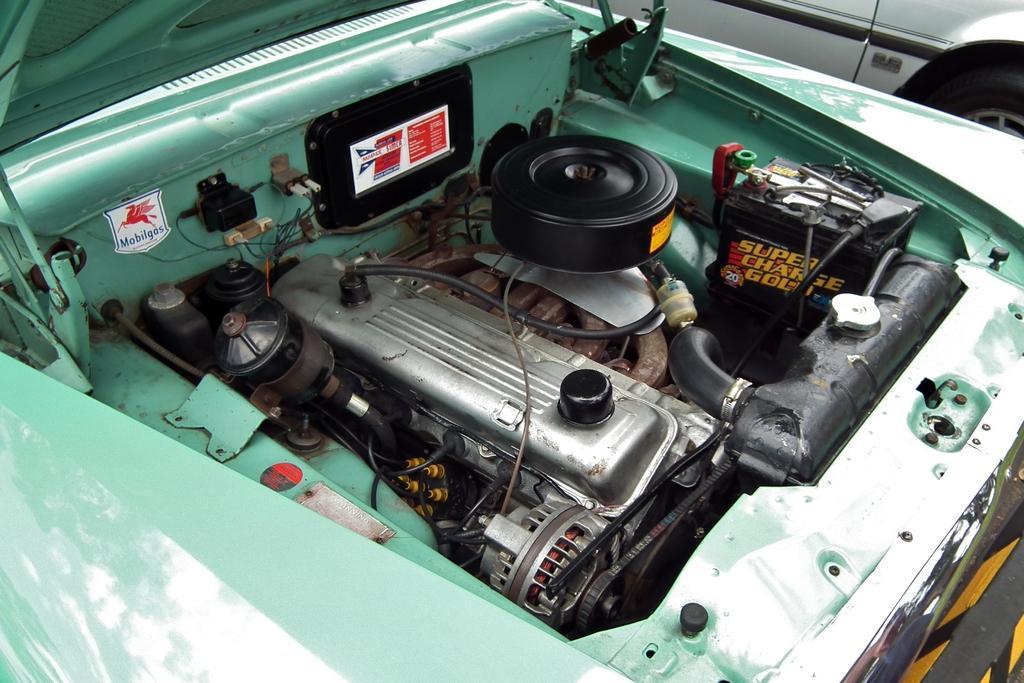Describe this image in one or two sentences. In this image I can see two cars and its interior parts. This image is taken may be in a garage. 